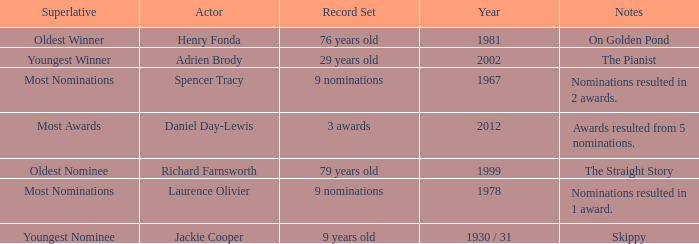In what year had the oldest winner? 1981.0. 